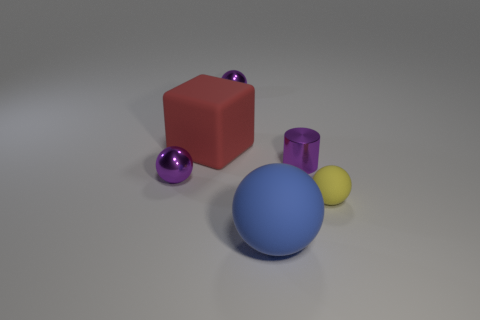There is a yellow rubber sphere; does it have the same size as the purple cylinder that is behind the large blue rubber ball?
Your answer should be very brief. Yes. There is a large blue thing that is the same shape as the yellow thing; what material is it?
Give a very brief answer. Rubber. What is the size of the purple metallic sphere in front of the small object behind the big object behind the blue object?
Your response must be concise. Small. Is the size of the purple shiny cylinder the same as the yellow sphere?
Your answer should be very brief. Yes. There is a tiny purple ball in front of the small purple thing that is behind the small metallic cylinder; what is its material?
Your answer should be compact. Metal. Do the small metal object behind the red matte object and the purple metal object that is on the right side of the blue matte object have the same shape?
Provide a short and direct response. No. Is the number of blue things that are behind the big blue thing the same as the number of red metallic cylinders?
Provide a short and direct response. Yes. There is a rubber thing in front of the tiny yellow thing; are there any tiny metal objects in front of it?
Provide a short and direct response. No. Is there any other thing that has the same color as the large ball?
Provide a short and direct response. No. Is the purple sphere right of the red rubber block made of the same material as the small purple cylinder?
Offer a terse response. Yes. 